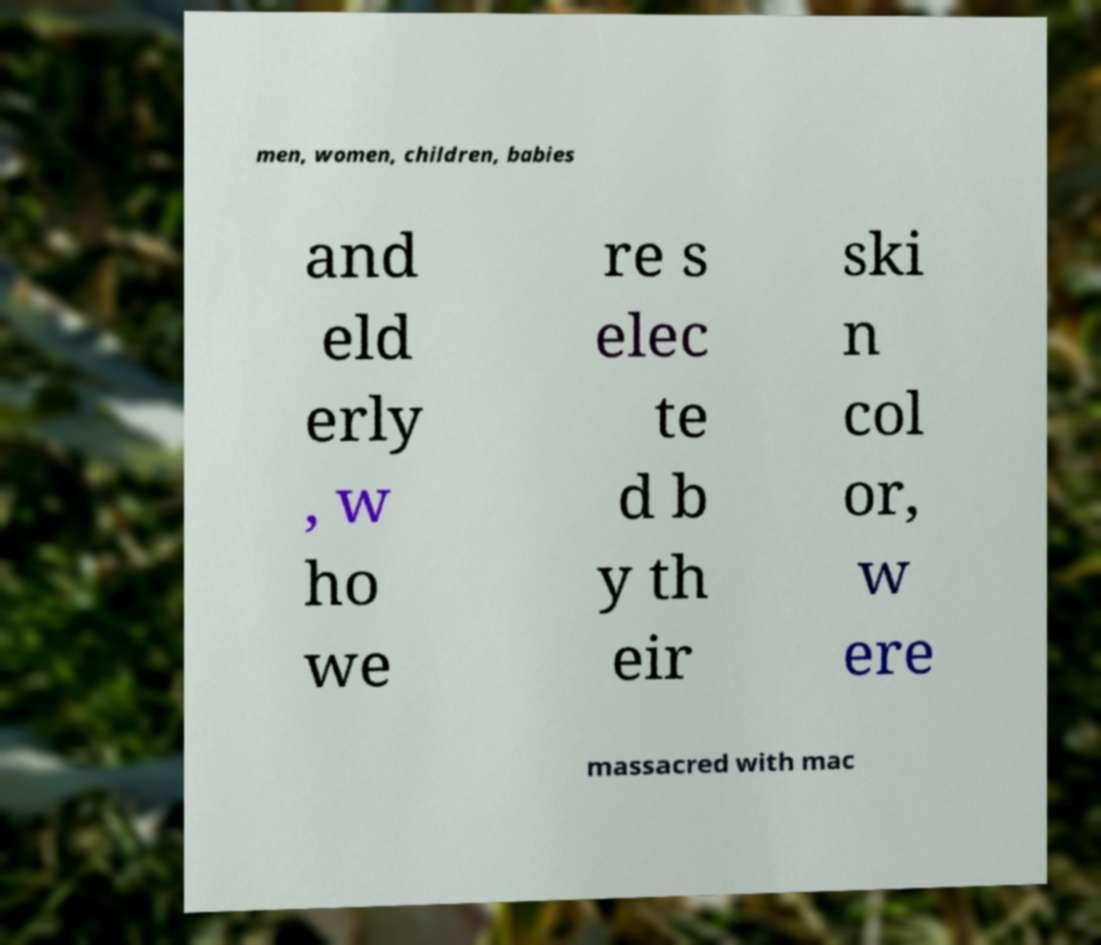I need the written content from this picture converted into text. Can you do that? men, women, children, babies and eld erly , w ho we re s elec te d b y th eir ski n col or, w ere massacred with mac 